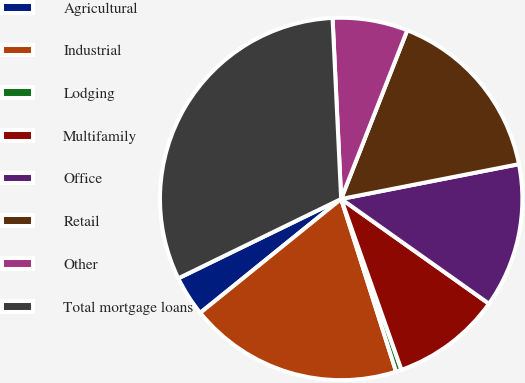<chart> <loc_0><loc_0><loc_500><loc_500><pie_chart><fcel>Agricultural<fcel>Industrial<fcel>Lodging<fcel>Multifamily<fcel>Office<fcel>Retail<fcel>Other<fcel>Total mortgage loans<nl><fcel>3.6%<fcel>19.08%<fcel>0.5%<fcel>9.79%<fcel>12.89%<fcel>15.98%<fcel>6.7%<fcel>31.46%<nl></chart> 